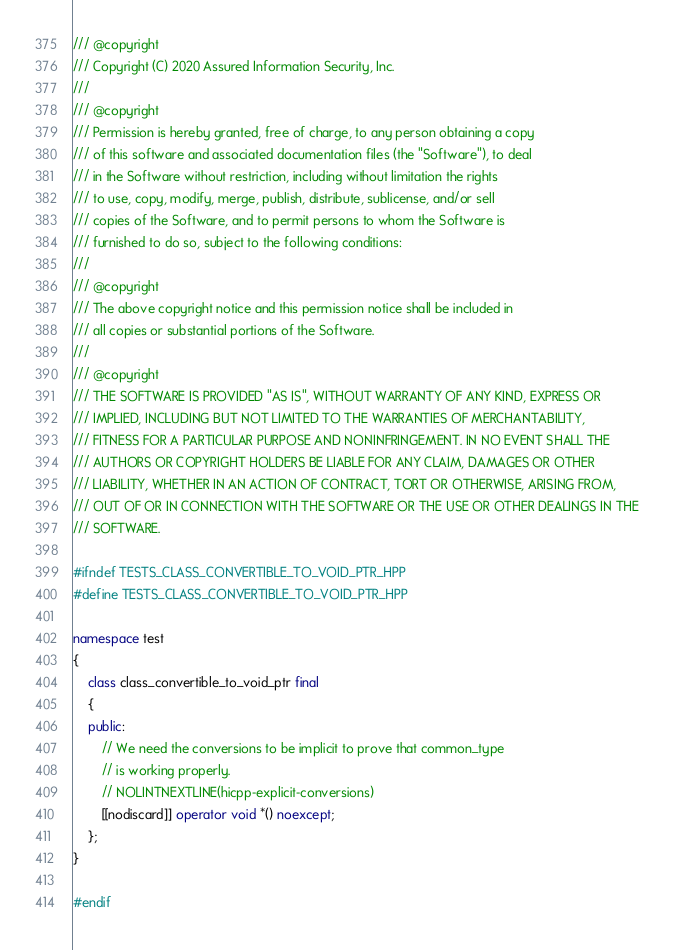Convert code to text. <code><loc_0><loc_0><loc_500><loc_500><_C++_>/// @copyright
/// Copyright (C) 2020 Assured Information Security, Inc.
///
/// @copyright
/// Permission is hereby granted, free of charge, to any person obtaining a copy
/// of this software and associated documentation files (the "Software"), to deal
/// in the Software without restriction, including without limitation the rights
/// to use, copy, modify, merge, publish, distribute, sublicense, and/or sell
/// copies of the Software, and to permit persons to whom the Software is
/// furnished to do so, subject to the following conditions:
///
/// @copyright
/// The above copyright notice and this permission notice shall be included in
/// all copies or substantial portions of the Software.
///
/// @copyright
/// THE SOFTWARE IS PROVIDED "AS IS", WITHOUT WARRANTY OF ANY KIND, EXPRESS OR
/// IMPLIED, INCLUDING BUT NOT LIMITED TO THE WARRANTIES OF MERCHANTABILITY,
/// FITNESS FOR A PARTICULAR PURPOSE AND NONINFRINGEMENT. IN NO EVENT SHALL THE
/// AUTHORS OR COPYRIGHT HOLDERS BE LIABLE FOR ANY CLAIM, DAMAGES OR OTHER
/// LIABILITY, WHETHER IN AN ACTION OF CONTRACT, TORT OR OTHERWISE, ARISING FROM,
/// OUT OF OR IN CONNECTION WITH THE SOFTWARE OR THE USE OR OTHER DEALINGS IN THE
/// SOFTWARE.

#ifndef TESTS_CLASS_CONVERTIBLE_TO_VOID_PTR_HPP
#define TESTS_CLASS_CONVERTIBLE_TO_VOID_PTR_HPP

namespace test
{
    class class_convertible_to_void_ptr final
    {
    public:
        // We need the conversions to be implicit to prove that common_type
        // is working properly.
        // NOLINTNEXTLINE(hicpp-explicit-conversions)
        [[nodiscard]] operator void *() noexcept;
    };
}

#endif
</code> 